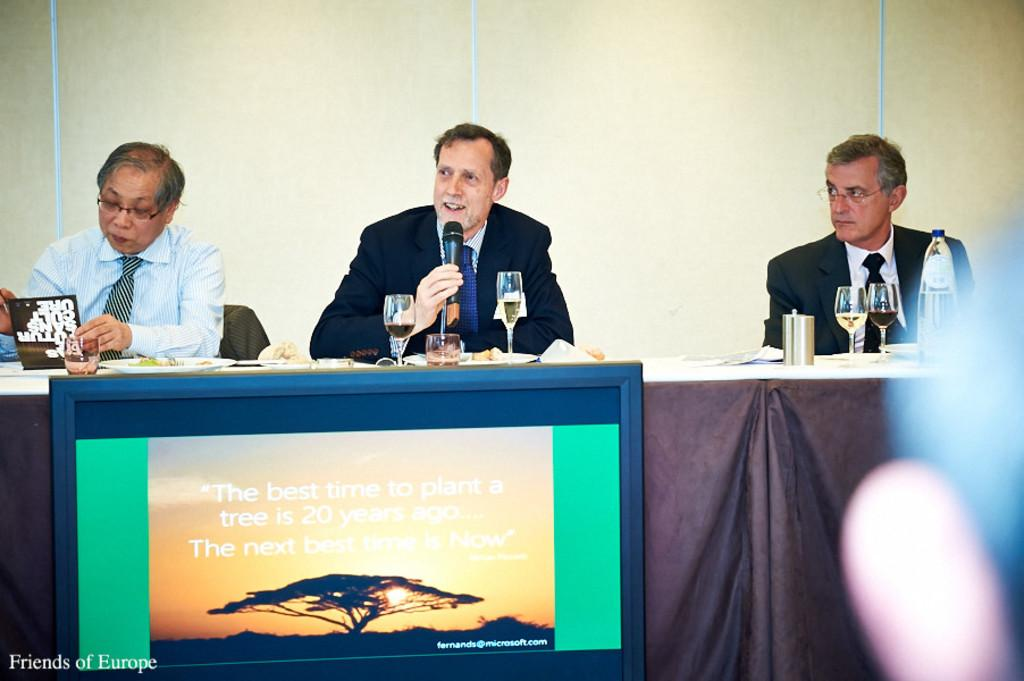<image>
Describe the image concisely. Speakers at a podium with a sign about planting trees. 